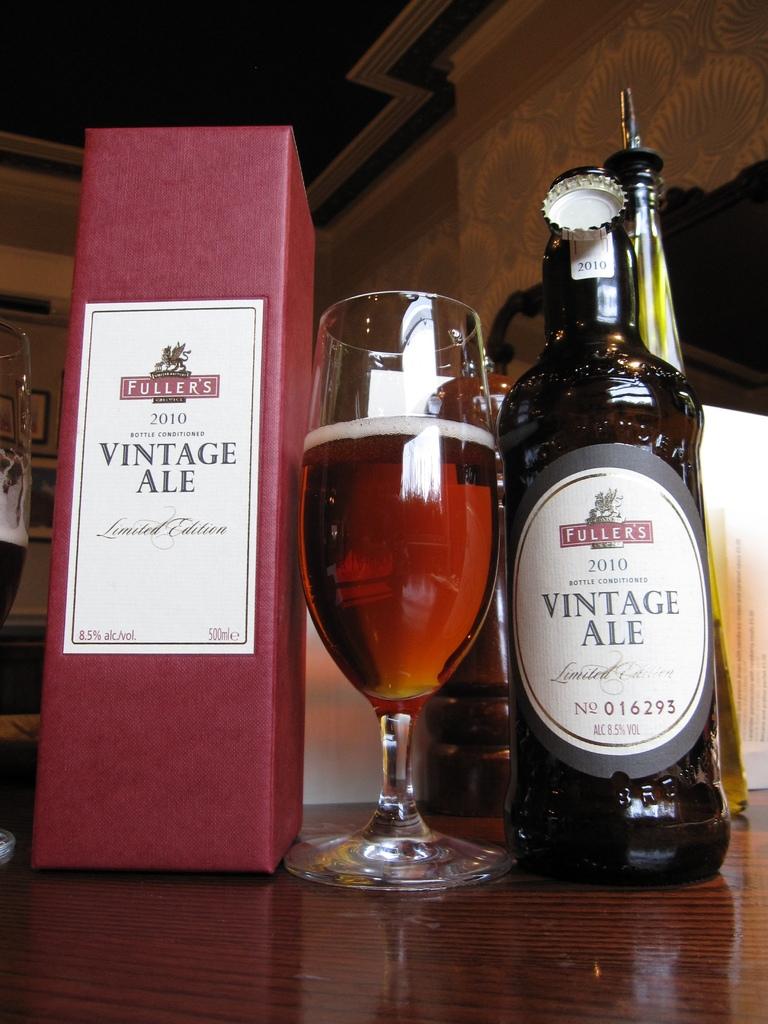What brand of ale is this?
Offer a terse response. Fuller's. What year was this ale bottled?
Provide a succinct answer. 2010. 